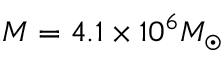Convert formula to latex. <formula><loc_0><loc_0><loc_500><loc_500>M = 4 . 1 \times 1 0 ^ { 6 } M _ { \odot }</formula> 